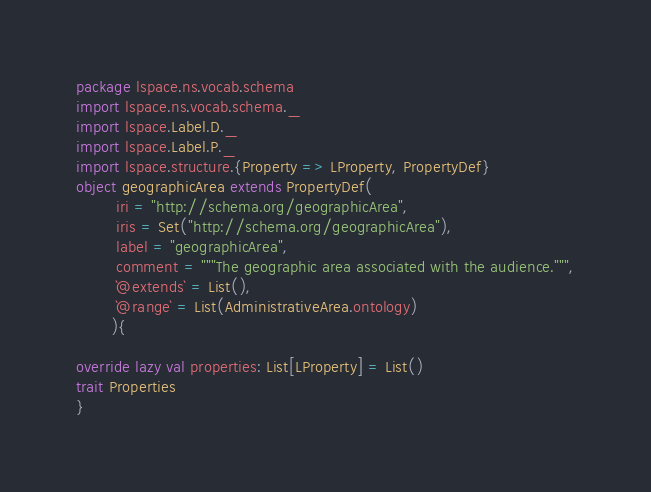<code> <loc_0><loc_0><loc_500><loc_500><_Scala_>package lspace.ns.vocab.schema
import lspace.ns.vocab.schema._
import lspace.Label.D._
import lspace.Label.P._
import lspace.structure.{Property => LProperty, PropertyDef}
object geographicArea extends PropertyDef(
        iri = "http://schema.org/geographicArea",
        iris = Set("http://schema.org/geographicArea"),
        label = "geographicArea",
        comment = """The geographic area associated with the audience.""",
        `@extends` = List(),
        `@range` = List(AdministrativeArea.ontology)
       ){

override lazy val properties: List[LProperty] = List()
trait Properties 
}</code> 